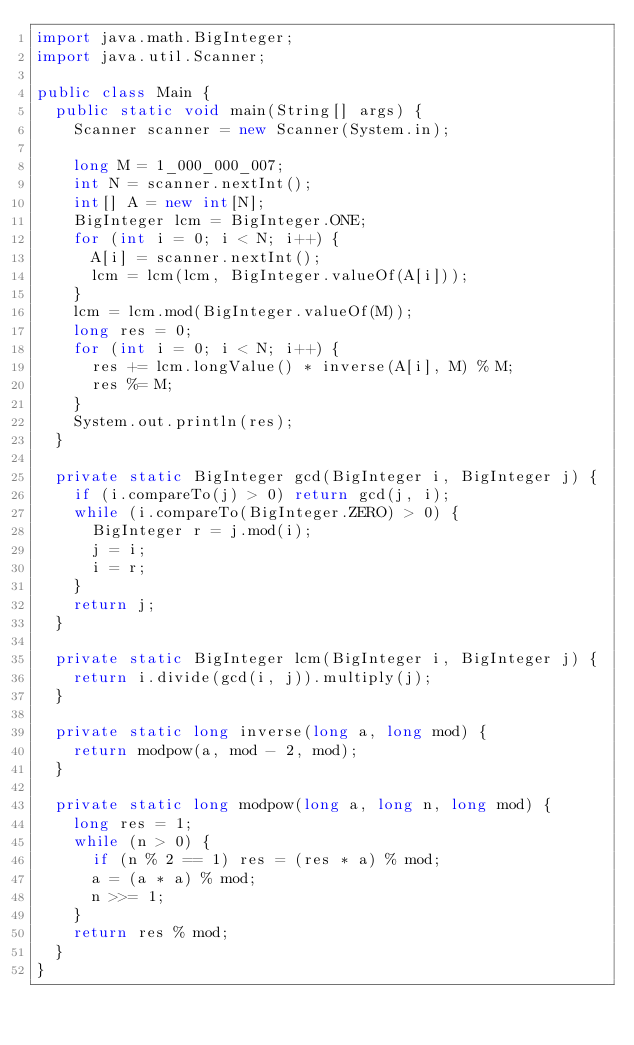<code> <loc_0><loc_0><loc_500><loc_500><_Java_>import java.math.BigInteger;
import java.util.Scanner;

public class Main {
  public static void main(String[] args) {
    Scanner scanner = new Scanner(System.in);

    long M = 1_000_000_007;
    int N = scanner.nextInt();
    int[] A = new int[N];
    BigInteger lcm = BigInteger.ONE;
    for (int i = 0; i < N; i++) {
      A[i] = scanner.nextInt();
      lcm = lcm(lcm, BigInteger.valueOf(A[i]));
    }
    lcm = lcm.mod(BigInteger.valueOf(M));
    long res = 0;
    for (int i = 0; i < N; i++) {
      res += lcm.longValue() * inverse(A[i], M) % M;
      res %= M;
    }
    System.out.println(res);
  }

  private static BigInteger gcd(BigInteger i, BigInteger j) {
    if (i.compareTo(j) > 0) return gcd(j, i);
    while (i.compareTo(BigInteger.ZERO) > 0) {
      BigInteger r = j.mod(i);
      j = i;
      i = r;
    }
    return j;
  }

  private static BigInteger lcm(BigInteger i, BigInteger j) {
    return i.divide(gcd(i, j)).multiply(j);
  }

  private static long inverse(long a, long mod) {
    return modpow(a, mod - 2, mod);
  }

  private static long modpow(long a, long n, long mod) {
    long res = 1;
    while (n > 0) {
      if (n % 2 == 1) res = (res * a) % mod;
      a = (a * a) % mod;
      n >>= 1;
    }
    return res % mod;
  }
}
</code> 